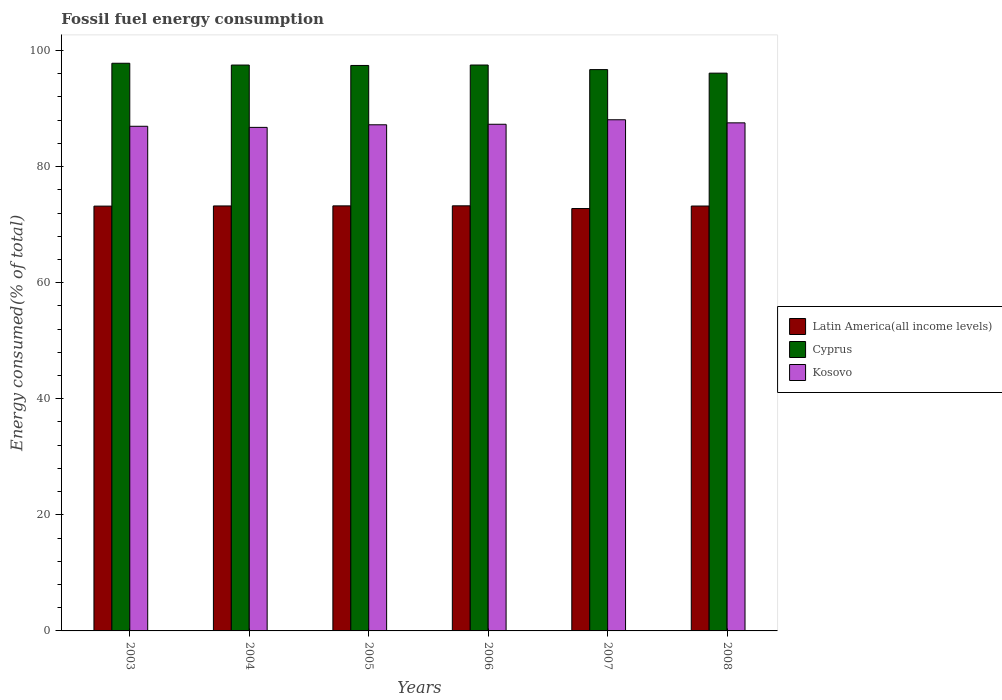How many different coloured bars are there?
Your answer should be very brief. 3. How many groups of bars are there?
Ensure brevity in your answer.  6. Are the number of bars per tick equal to the number of legend labels?
Your response must be concise. Yes. How many bars are there on the 1st tick from the right?
Keep it short and to the point. 3. In how many cases, is the number of bars for a given year not equal to the number of legend labels?
Your response must be concise. 0. What is the percentage of energy consumed in Kosovo in 2006?
Your answer should be very brief. 87.3. Across all years, what is the maximum percentage of energy consumed in Kosovo?
Offer a terse response. 88.07. Across all years, what is the minimum percentage of energy consumed in Kosovo?
Your answer should be compact. 86.76. In which year was the percentage of energy consumed in Latin America(all income levels) minimum?
Your answer should be very brief. 2007. What is the total percentage of energy consumed in Latin America(all income levels) in the graph?
Ensure brevity in your answer.  438.89. What is the difference between the percentage of energy consumed in Cyprus in 2003 and that in 2008?
Provide a succinct answer. 1.7. What is the difference between the percentage of energy consumed in Latin America(all income levels) in 2006 and the percentage of energy consumed in Cyprus in 2004?
Keep it short and to the point. -24.26. What is the average percentage of energy consumed in Kosovo per year?
Make the answer very short. 87.31. In the year 2006, what is the difference between the percentage of energy consumed in Kosovo and percentage of energy consumed in Latin America(all income levels)?
Offer a terse response. 14.05. In how many years, is the percentage of energy consumed in Kosovo greater than 48 %?
Offer a terse response. 6. What is the ratio of the percentage of energy consumed in Kosovo in 2003 to that in 2008?
Your answer should be very brief. 0.99. Is the difference between the percentage of energy consumed in Kosovo in 2004 and 2006 greater than the difference between the percentage of energy consumed in Latin America(all income levels) in 2004 and 2006?
Your answer should be compact. No. What is the difference between the highest and the second highest percentage of energy consumed in Cyprus?
Your answer should be compact. 0.3. What is the difference between the highest and the lowest percentage of energy consumed in Kosovo?
Your response must be concise. 1.31. In how many years, is the percentage of energy consumed in Cyprus greater than the average percentage of energy consumed in Cyprus taken over all years?
Offer a very short reply. 4. What does the 3rd bar from the left in 2004 represents?
Your answer should be compact. Kosovo. What does the 3rd bar from the right in 2003 represents?
Your response must be concise. Latin America(all income levels). How many bars are there?
Provide a succinct answer. 18. How many years are there in the graph?
Ensure brevity in your answer.  6. Does the graph contain any zero values?
Your answer should be compact. No. Where does the legend appear in the graph?
Offer a terse response. Center right. What is the title of the graph?
Make the answer very short. Fossil fuel energy consumption. What is the label or title of the X-axis?
Ensure brevity in your answer.  Years. What is the label or title of the Y-axis?
Offer a very short reply. Energy consumed(% of total). What is the Energy consumed(% of total) in Latin America(all income levels) in 2003?
Your answer should be very brief. 73.19. What is the Energy consumed(% of total) of Cyprus in 2003?
Your answer should be compact. 97.81. What is the Energy consumed(% of total) of Kosovo in 2003?
Your response must be concise. 86.95. What is the Energy consumed(% of total) of Latin America(all income levels) in 2004?
Offer a very short reply. 73.23. What is the Energy consumed(% of total) in Cyprus in 2004?
Ensure brevity in your answer.  97.5. What is the Energy consumed(% of total) of Kosovo in 2004?
Your answer should be compact. 86.76. What is the Energy consumed(% of total) of Latin America(all income levels) in 2005?
Offer a terse response. 73.24. What is the Energy consumed(% of total) in Cyprus in 2005?
Keep it short and to the point. 97.43. What is the Energy consumed(% of total) of Kosovo in 2005?
Your answer should be very brief. 87.21. What is the Energy consumed(% of total) in Latin America(all income levels) in 2006?
Offer a very short reply. 73.25. What is the Energy consumed(% of total) of Cyprus in 2006?
Give a very brief answer. 97.51. What is the Energy consumed(% of total) in Kosovo in 2006?
Your response must be concise. 87.3. What is the Energy consumed(% of total) of Latin America(all income levels) in 2007?
Offer a terse response. 72.78. What is the Energy consumed(% of total) of Cyprus in 2007?
Your answer should be compact. 96.72. What is the Energy consumed(% of total) in Kosovo in 2007?
Offer a terse response. 88.07. What is the Energy consumed(% of total) in Latin America(all income levels) in 2008?
Your answer should be very brief. 73.21. What is the Energy consumed(% of total) in Cyprus in 2008?
Your response must be concise. 96.11. What is the Energy consumed(% of total) in Kosovo in 2008?
Keep it short and to the point. 87.54. Across all years, what is the maximum Energy consumed(% of total) in Latin America(all income levels)?
Give a very brief answer. 73.25. Across all years, what is the maximum Energy consumed(% of total) of Cyprus?
Your answer should be very brief. 97.81. Across all years, what is the maximum Energy consumed(% of total) of Kosovo?
Provide a succinct answer. 88.07. Across all years, what is the minimum Energy consumed(% of total) in Latin America(all income levels)?
Give a very brief answer. 72.78. Across all years, what is the minimum Energy consumed(% of total) of Cyprus?
Offer a terse response. 96.11. Across all years, what is the minimum Energy consumed(% of total) in Kosovo?
Give a very brief answer. 86.76. What is the total Energy consumed(% of total) in Latin America(all income levels) in the graph?
Offer a very short reply. 438.89. What is the total Energy consumed(% of total) in Cyprus in the graph?
Provide a short and direct response. 583.07. What is the total Energy consumed(% of total) of Kosovo in the graph?
Provide a succinct answer. 523.84. What is the difference between the Energy consumed(% of total) of Latin America(all income levels) in 2003 and that in 2004?
Give a very brief answer. -0.03. What is the difference between the Energy consumed(% of total) of Cyprus in 2003 and that in 2004?
Make the answer very short. 0.31. What is the difference between the Energy consumed(% of total) of Kosovo in 2003 and that in 2004?
Make the answer very short. 0.19. What is the difference between the Energy consumed(% of total) of Latin America(all income levels) in 2003 and that in 2005?
Your response must be concise. -0.04. What is the difference between the Energy consumed(% of total) in Cyprus in 2003 and that in 2005?
Your answer should be very brief. 0.38. What is the difference between the Energy consumed(% of total) of Kosovo in 2003 and that in 2005?
Offer a very short reply. -0.26. What is the difference between the Energy consumed(% of total) in Latin America(all income levels) in 2003 and that in 2006?
Offer a very short reply. -0.05. What is the difference between the Energy consumed(% of total) of Cyprus in 2003 and that in 2006?
Your answer should be very brief. 0.3. What is the difference between the Energy consumed(% of total) in Kosovo in 2003 and that in 2006?
Provide a succinct answer. -0.35. What is the difference between the Energy consumed(% of total) of Latin America(all income levels) in 2003 and that in 2007?
Your answer should be compact. 0.42. What is the difference between the Energy consumed(% of total) of Cyprus in 2003 and that in 2007?
Ensure brevity in your answer.  1.09. What is the difference between the Energy consumed(% of total) of Kosovo in 2003 and that in 2007?
Ensure brevity in your answer.  -1.12. What is the difference between the Energy consumed(% of total) in Latin America(all income levels) in 2003 and that in 2008?
Keep it short and to the point. -0.02. What is the difference between the Energy consumed(% of total) in Cyprus in 2003 and that in 2008?
Your answer should be very brief. 1.7. What is the difference between the Energy consumed(% of total) of Kosovo in 2003 and that in 2008?
Make the answer very short. -0.59. What is the difference between the Energy consumed(% of total) of Latin America(all income levels) in 2004 and that in 2005?
Your response must be concise. -0.01. What is the difference between the Energy consumed(% of total) of Cyprus in 2004 and that in 2005?
Provide a short and direct response. 0.07. What is the difference between the Energy consumed(% of total) in Kosovo in 2004 and that in 2005?
Ensure brevity in your answer.  -0.45. What is the difference between the Energy consumed(% of total) in Latin America(all income levels) in 2004 and that in 2006?
Your answer should be very brief. -0.02. What is the difference between the Energy consumed(% of total) in Cyprus in 2004 and that in 2006?
Your answer should be compact. -0.01. What is the difference between the Energy consumed(% of total) of Kosovo in 2004 and that in 2006?
Provide a succinct answer. -0.54. What is the difference between the Energy consumed(% of total) in Latin America(all income levels) in 2004 and that in 2007?
Your answer should be compact. 0.45. What is the difference between the Energy consumed(% of total) in Cyprus in 2004 and that in 2007?
Your answer should be very brief. 0.78. What is the difference between the Energy consumed(% of total) in Kosovo in 2004 and that in 2007?
Your answer should be very brief. -1.31. What is the difference between the Energy consumed(% of total) in Latin America(all income levels) in 2004 and that in 2008?
Ensure brevity in your answer.  0.01. What is the difference between the Energy consumed(% of total) in Cyprus in 2004 and that in 2008?
Offer a very short reply. 1.4. What is the difference between the Energy consumed(% of total) in Kosovo in 2004 and that in 2008?
Keep it short and to the point. -0.78. What is the difference between the Energy consumed(% of total) of Latin America(all income levels) in 2005 and that in 2006?
Provide a succinct answer. -0.01. What is the difference between the Energy consumed(% of total) of Cyprus in 2005 and that in 2006?
Keep it short and to the point. -0.07. What is the difference between the Energy consumed(% of total) of Kosovo in 2005 and that in 2006?
Provide a succinct answer. -0.09. What is the difference between the Energy consumed(% of total) of Latin America(all income levels) in 2005 and that in 2007?
Make the answer very short. 0.46. What is the difference between the Energy consumed(% of total) in Cyprus in 2005 and that in 2007?
Offer a very short reply. 0.71. What is the difference between the Energy consumed(% of total) of Kosovo in 2005 and that in 2007?
Make the answer very short. -0.87. What is the difference between the Energy consumed(% of total) in Latin America(all income levels) in 2005 and that in 2008?
Offer a very short reply. 0.03. What is the difference between the Energy consumed(% of total) of Cyprus in 2005 and that in 2008?
Your answer should be very brief. 1.33. What is the difference between the Energy consumed(% of total) of Kosovo in 2005 and that in 2008?
Make the answer very short. -0.33. What is the difference between the Energy consumed(% of total) in Latin America(all income levels) in 2006 and that in 2007?
Give a very brief answer. 0.47. What is the difference between the Energy consumed(% of total) in Cyprus in 2006 and that in 2007?
Ensure brevity in your answer.  0.79. What is the difference between the Energy consumed(% of total) in Kosovo in 2006 and that in 2007?
Your answer should be very brief. -0.77. What is the difference between the Energy consumed(% of total) of Latin America(all income levels) in 2006 and that in 2008?
Provide a succinct answer. 0.04. What is the difference between the Energy consumed(% of total) in Cyprus in 2006 and that in 2008?
Offer a terse response. 1.4. What is the difference between the Energy consumed(% of total) of Kosovo in 2006 and that in 2008?
Your response must be concise. -0.24. What is the difference between the Energy consumed(% of total) in Latin America(all income levels) in 2007 and that in 2008?
Make the answer very short. -0.43. What is the difference between the Energy consumed(% of total) of Cyprus in 2007 and that in 2008?
Provide a short and direct response. 0.61. What is the difference between the Energy consumed(% of total) in Kosovo in 2007 and that in 2008?
Provide a succinct answer. 0.53. What is the difference between the Energy consumed(% of total) of Latin America(all income levels) in 2003 and the Energy consumed(% of total) of Cyprus in 2004?
Your answer should be compact. -24.31. What is the difference between the Energy consumed(% of total) of Latin America(all income levels) in 2003 and the Energy consumed(% of total) of Kosovo in 2004?
Give a very brief answer. -13.57. What is the difference between the Energy consumed(% of total) in Cyprus in 2003 and the Energy consumed(% of total) in Kosovo in 2004?
Offer a terse response. 11.05. What is the difference between the Energy consumed(% of total) in Latin America(all income levels) in 2003 and the Energy consumed(% of total) in Cyprus in 2005?
Your response must be concise. -24.24. What is the difference between the Energy consumed(% of total) of Latin America(all income levels) in 2003 and the Energy consumed(% of total) of Kosovo in 2005?
Offer a very short reply. -14.01. What is the difference between the Energy consumed(% of total) of Cyprus in 2003 and the Energy consumed(% of total) of Kosovo in 2005?
Your answer should be very brief. 10.6. What is the difference between the Energy consumed(% of total) of Latin America(all income levels) in 2003 and the Energy consumed(% of total) of Cyprus in 2006?
Your answer should be very brief. -24.31. What is the difference between the Energy consumed(% of total) of Latin America(all income levels) in 2003 and the Energy consumed(% of total) of Kosovo in 2006?
Your response must be concise. -14.1. What is the difference between the Energy consumed(% of total) in Cyprus in 2003 and the Energy consumed(% of total) in Kosovo in 2006?
Make the answer very short. 10.51. What is the difference between the Energy consumed(% of total) in Latin America(all income levels) in 2003 and the Energy consumed(% of total) in Cyprus in 2007?
Make the answer very short. -23.52. What is the difference between the Energy consumed(% of total) of Latin America(all income levels) in 2003 and the Energy consumed(% of total) of Kosovo in 2007?
Your answer should be very brief. -14.88. What is the difference between the Energy consumed(% of total) of Cyprus in 2003 and the Energy consumed(% of total) of Kosovo in 2007?
Offer a very short reply. 9.74. What is the difference between the Energy consumed(% of total) in Latin America(all income levels) in 2003 and the Energy consumed(% of total) in Cyprus in 2008?
Your answer should be very brief. -22.91. What is the difference between the Energy consumed(% of total) in Latin America(all income levels) in 2003 and the Energy consumed(% of total) in Kosovo in 2008?
Offer a terse response. -14.35. What is the difference between the Energy consumed(% of total) in Cyprus in 2003 and the Energy consumed(% of total) in Kosovo in 2008?
Your answer should be very brief. 10.27. What is the difference between the Energy consumed(% of total) of Latin America(all income levels) in 2004 and the Energy consumed(% of total) of Cyprus in 2005?
Your response must be concise. -24.21. What is the difference between the Energy consumed(% of total) of Latin America(all income levels) in 2004 and the Energy consumed(% of total) of Kosovo in 2005?
Give a very brief answer. -13.98. What is the difference between the Energy consumed(% of total) in Cyprus in 2004 and the Energy consumed(% of total) in Kosovo in 2005?
Give a very brief answer. 10.29. What is the difference between the Energy consumed(% of total) of Latin America(all income levels) in 2004 and the Energy consumed(% of total) of Cyprus in 2006?
Offer a very short reply. -24.28. What is the difference between the Energy consumed(% of total) in Latin America(all income levels) in 2004 and the Energy consumed(% of total) in Kosovo in 2006?
Give a very brief answer. -14.07. What is the difference between the Energy consumed(% of total) of Cyprus in 2004 and the Energy consumed(% of total) of Kosovo in 2006?
Make the answer very short. 10.2. What is the difference between the Energy consumed(% of total) in Latin America(all income levels) in 2004 and the Energy consumed(% of total) in Cyprus in 2007?
Offer a very short reply. -23.49. What is the difference between the Energy consumed(% of total) of Latin America(all income levels) in 2004 and the Energy consumed(% of total) of Kosovo in 2007?
Offer a very short reply. -14.85. What is the difference between the Energy consumed(% of total) in Cyprus in 2004 and the Energy consumed(% of total) in Kosovo in 2007?
Your response must be concise. 9.43. What is the difference between the Energy consumed(% of total) in Latin America(all income levels) in 2004 and the Energy consumed(% of total) in Cyprus in 2008?
Keep it short and to the point. -22.88. What is the difference between the Energy consumed(% of total) in Latin America(all income levels) in 2004 and the Energy consumed(% of total) in Kosovo in 2008?
Provide a succinct answer. -14.32. What is the difference between the Energy consumed(% of total) of Cyprus in 2004 and the Energy consumed(% of total) of Kosovo in 2008?
Provide a short and direct response. 9.96. What is the difference between the Energy consumed(% of total) of Latin America(all income levels) in 2005 and the Energy consumed(% of total) of Cyprus in 2006?
Provide a succinct answer. -24.27. What is the difference between the Energy consumed(% of total) of Latin America(all income levels) in 2005 and the Energy consumed(% of total) of Kosovo in 2006?
Your response must be concise. -14.06. What is the difference between the Energy consumed(% of total) in Cyprus in 2005 and the Energy consumed(% of total) in Kosovo in 2006?
Offer a very short reply. 10.13. What is the difference between the Energy consumed(% of total) in Latin America(all income levels) in 2005 and the Energy consumed(% of total) in Cyprus in 2007?
Offer a very short reply. -23.48. What is the difference between the Energy consumed(% of total) of Latin America(all income levels) in 2005 and the Energy consumed(% of total) of Kosovo in 2007?
Your response must be concise. -14.84. What is the difference between the Energy consumed(% of total) in Cyprus in 2005 and the Energy consumed(% of total) in Kosovo in 2007?
Keep it short and to the point. 9.36. What is the difference between the Energy consumed(% of total) in Latin America(all income levels) in 2005 and the Energy consumed(% of total) in Cyprus in 2008?
Your response must be concise. -22.87. What is the difference between the Energy consumed(% of total) in Latin America(all income levels) in 2005 and the Energy consumed(% of total) in Kosovo in 2008?
Keep it short and to the point. -14.3. What is the difference between the Energy consumed(% of total) in Cyprus in 2005 and the Energy consumed(% of total) in Kosovo in 2008?
Your answer should be compact. 9.89. What is the difference between the Energy consumed(% of total) in Latin America(all income levels) in 2006 and the Energy consumed(% of total) in Cyprus in 2007?
Offer a terse response. -23.47. What is the difference between the Energy consumed(% of total) in Latin America(all income levels) in 2006 and the Energy consumed(% of total) in Kosovo in 2007?
Ensure brevity in your answer.  -14.83. What is the difference between the Energy consumed(% of total) in Cyprus in 2006 and the Energy consumed(% of total) in Kosovo in 2007?
Provide a short and direct response. 9.43. What is the difference between the Energy consumed(% of total) in Latin America(all income levels) in 2006 and the Energy consumed(% of total) in Cyprus in 2008?
Your response must be concise. -22.86. What is the difference between the Energy consumed(% of total) of Latin America(all income levels) in 2006 and the Energy consumed(% of total) of Kosovo in 2008?
Your response must be concise. -14.3. What is the difference between the Energy consumed(% of total) of Cyprus in 2006 and the Energy consumed(% of total) of Kosovo in 2008?
Provide a succinct answer. 9.96. What is the difference between the Energy consumed(% of total) in Latin America(all income levels) in 2007 and the Energy consumed(% of total) in Cyprus in 2008?
Your response must be concise. -23.33. What is the difference between the Energy consumed(% of total) of Latin America(all income levels) in 2007 and the Energy consumed(% of total) of Kosovo in 2008?
Offer a very short reply. -14.77. What is the difference between the Energy consumed(% of total) in Cyprus in 2007 and the Energy consumed(% of total) in Kosovo in 2008?
Give a very brief answer. 9.17. What is the average Energy consumed(% of total) of Latin America(all income levels) per year?
Your response must be concise. 73.15. What is the average Energy consumed(% of total) in Cyprus per year?
Ensure brevity in your answer.  97.18. What is the average Energy consumed(% of total) of Kosovo per year?
Keep it short and to the point. 87.31. In the year 2003, what is the difference between the Energy consumed(% of total) in Latin America(all income levels) and Energy consumed(% of total) in Cyprus?
Make the answer very short. -24.62. In the year 2003, what is the difference between the Energy consumed(% of total) of Latin America(all income levels) and Energy consumed(% of total) of Kosovo?
Make the answer very short. -13.76. In the year 2003, what is the difference between the Energy consumed(% of total) in Cyprus and Energy consumed(% of total) in Kosovo?
Make the answer very short. 10.86. In the year 2004, what is the difference between the Energy consumed(% of total) in Latin America(all income levels) and Energy consumed(% of total) in Cyprus?
Provide a short and direct response. -24.28. In the year 2004, what is the difference between the Energy consumed(% of total) in Latin America(all income levels) and Energy consumed(% of total) in Kosovo?
Offer a terse response. -13.54. In the year 2004, what is the difference between the Energy consumed(% of total) in Cyprus and Energy consumed(% of total) in Kosovo?
Keep it short and to the point. 10.74. In the year 2005, what is the difference between the Energy consumed(% of total) of Latin America(all income levels) and Energy consumed(% of total) of Cyprus?
Provide a succinct answer. -24.19. In the year 2005, what is the difference between the Energy consumed(% of total) in Latin America(all income levels) and Energy consumed(% of total) in Kosovo?
Provide a short and direct response. -13.97. In the year 2005, what is the difference between the Energy consumed(% of total) in Cyprus and Energy consumed(% of total) in Kosovo?
Provide a short and direct response. 10.22. In the year 2006, what is the difference between the Energy consumed(% of total) in Latin America(all income levels) and Energy consumed(% of total) in Cyprus?
Offer a very short reply. -24.26. In the year 2006, what is the difference between the Energy consumed(% of total) in Latin America(all income levels) and Energy consumed(% of total) in Kosovo?
Offer a very short reply. -14.05. In the year 2006, what is the difference between the Energy consumed(% of total) of Cyprus and Energy consumed(% of total) of Kosovo?
Keep it short and to the point. 10.21. In the year 2007, what is the difference between the Energy consumed(% of total) of Latin America(all income levels) and Energy consumed(% of total) of Cyprus?
Offer a terse response. -23.94. In the year 2007, what is the difference between the Energy consumed(% of total) of Latin America(all income levels) and Energy consumed(% of total) of Kosovo?
Offer a terse response. -15.3. In the year 2007, what is the difference between the Energy consumed(% of total) of Cyprus and Energy consumed(% of total) of Kosovo?
Offer a terse response. 8.64. In the year 2008, what is the difference between the Energy consumed(% of total) of Latin America(all income levels) and Energy consumed(% of total) of Cyprus?
Make the answer very short. -22.9. In the year 2008, what is the difference between the Energy consumed(% of total) of Latin America(all income levels) and Energy consumed(% of total) of Kosovo?
Offer a terse response. -14.33. In the year 2008, what is the difference between the Energy consumed(% of total) of Cyprus and Energy consumed(% of total) of Kosovo?
Keep it short and to the point. 8.56. What is the ratio of the Energy consumed(% of total) in Cyprus in 2003 to that in 2004?
Provide a succinct answer. 1. What is the ratio of the Energy consumed(% of total) in Kosovo in 2003 to that in 2004?
Provide a succinct answer. 1. What is the ratio of the Energy consumed(% of total) in Latin America(all income levels) in 2003 to that in 2005?
Keep it short and to the point. 1. What is the ratio of the Energy consumed(% of total) in Cyprus in 2003 to that in 2005?
Make the answer very short. 1. What is the ratio of the Energy consumed(% of total) in Kosovo in 2003 to that in 2005?
Your answer should be very brief. 1. What is the ratio of the Energy consumed(% of total) of Kosovo in 2003 to that in 2006?
Offer a very short reply. 1. What is the ratio of the Energy consumed(% of total) in Latin America(all income levels) in 2003 to that in 2007?
Provide a succinct answer. 1.01. What is the ratio of the Energy consumed(% of total) in Cyprus in 2003 to that in 2007?
Make the answer very short. 1.01. What is the ratio of the Energy consumed(% of total) in Kosovo in 2003 to that in 2007?
Your answer should be very brief. 0.99. What is the ratio of the Energy consumed(% of total) of Latin America(all income levels) in 2003 to that in 2008?
Your answer should be compact. 1. What is the ratio of the Energy consumed(% of total) in Cyprus in 2003 to that in 2008?
Offer a terse response. 1.02. What is the ratio of the Energy consumed(% of total) in Kosovo in 2003 to that in 2008?
Offer a very short reply. 0.99. What is the ratio of the Energy consumed(% of total) of Cyprus in 2004 to that in 2006?
Your answer should be compact. 1. What is the ratio of the Energy consumed(% of total) in Kosovo in 2004 to that in 2006?
Offer a very short reply. 0.99. What is the ratio of the Energy consumed(% of total) in Cyprus in 2004 to that in 2007?
Keep it short and to the point. 1.01. What is the ratio of the Energy consumed(% of total) in Kosovo in 2004 to that in 2007?
Your answer should be very brief. 0.99. What is the ratio of the Energy consumed(% of total) of Latin America(all income levels) in 2004 to that in 2008?
Ensure brevity in your answer.  1. What is the ratio of the Energy consumed(% of total) of Cyprus in 2004 to that in 2008?
Offer a terse response. 1.01. What is the ratio of the Energy consumed(% of total) in Kosovo in 2004 to that in 2008?
Give a very brief answer. 0.99. What is the ratio of the Energy consumed(% of total) of Kosovo in 2005 to that in 2006?
Your answer should be very brief. 1. What is the ratio of the Energy consumed(% of total) of Cyprus in 2005 to that in 2007?
Offer a terse response. 1.01. What is the ratio of the Energy consumed(% of total) of Kosovo in 2005 to that in 2007?
Offer a very short reply. 0.99. What is the ratio of the Energy consumed(% of total) of Latin America(all income levels) in 2005 to that in 2008?
Your answer should be compact. 1. What is the ratio of the Energy consumed(% of total) of Cyprus in 2005 to that in 2008?
Keep it short and to the point. 1.01. What is the ratio of the Energy consumed(% of total) of Kosovo in 2005 to that in 2008?
Your answer should be compact. 1. What is the ratio of the Energy consumed(% of total) of Latin America(all income levels) in 2006 to that in 2007?
Provide a short and direct response. 1.01. What is the ratio of the Energy consumed(% of total) in Cyprus in 2006 to that in 2007?
Give a very brief answer. 1.01. What is the ratio of the Energy consumed(% of total) in Latin America(all income levels) in 2006 to that in 2008?
Provide a short and direct response. 1. What is the ratio of the Energy consumed(% of total) of Cyprus in 2006 to that in 2008?
Offer a terse response. 1.01. What is the ratio of the Energy consumed(% of total) of Kosovo in 2006 to that in 2008?
Ensure brevity in your answer.  1. What is the ratio of the Energy consumed(% of total) in Cyprus in 2007 to that in 2008?
Offer a very short reply. 1.01. What is the difference between the highest and the second highest Energy consumed(% of total) in Latin America(all income levels)?
Ensure brevity in your answer.  0.01. What is the difference between the highest and the second highest Energy consumed(% of total) of Cyprus?
Offer a terse response. 0.3. What is the difference between the highest and the second highest Energy consumed(% of total) in Kosovo?
Keep it short and to the point. 0.53. What is the difference between the highest and the lowest Energy consumed(% of total) of Latin America(all income levels)?
Give a very brief answer. 0.47. What is the difference between the highest and the lowest Energy consumed(% of total) in Cyprus?
Your response must be concise. 1.7. What is the difference between the highest and the lowest Energy consumed(% of total) in Kosovo?
Provide a short and direct response. 1.31. 